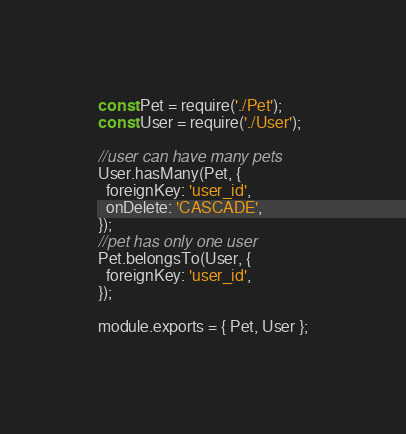Convert code to text. <code><loc_0><loc_0><loc_500><loc_500><_JavaScript_>const Pet = require('./Pet');
const User = require('./User');

//user can have many pets
User.hasMany(Pet, {
  foreignKey: 'user_id',
  onDelete: 'CASCADE',
});
//pet has only one user
Pet.belongsTo(User, {
  foreignKey: 'user_id',
});

module.exports = { Pet, User };
</code> 